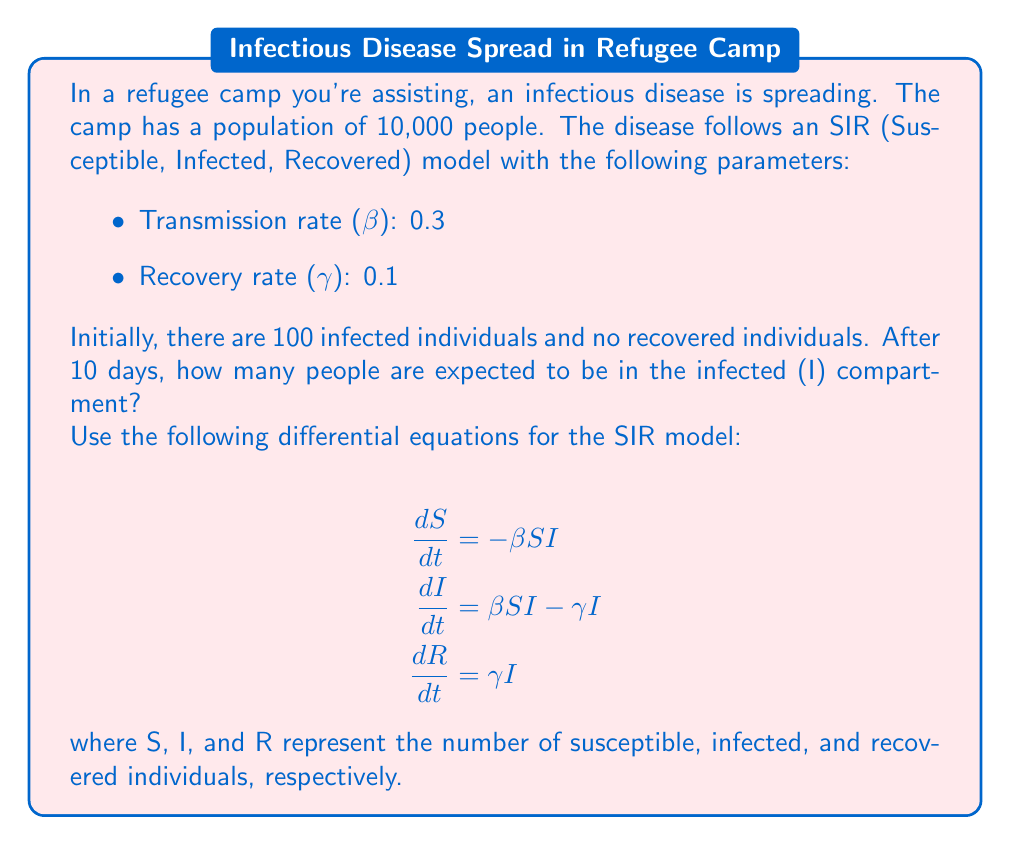Give your solution to this math problem. To solve this problem, we need to use numerical methods to approximate the solution of the SIR model differential equations. We'll use the Euler method with a small time step to estimate the number of infected individuals after 10 days.

1. Initialize the variables:
   S₀ = 9900 (initial susceptible)
   I₀ = 100 (initial infected)
   R₀ = 0 (initial recovered)
   N = 10000 (total population)
   β = 0.3 (transmission rate)
   γ = 0.1 (recovery rate)
   Δt = 0.1 (time step in days)
   T = 10 (total time in days)

2. Calculate the number of steps:
   steps = T / Δt = 10 / 0.1 = 100

3. Use the Euler method to approximate the solution:
   For each step i from 1 to 100:
   
   $$S_{i+1} = S_i + (-\beta S_i I_i / N) \cdot \Delta t$$
   $$I_{i+1} = I_i + (\beta S_i I_i / N - \gamma I_i) \cdot \Delta t$$
   $$R_{i+1} = R_i + (\gamma I_i) \cdot \Delta t$$

4. Implement the algorithm (pseudo-code):

```
S = 9900
I = 100
R = 0
N = 10000
beta = 0.3
gamma = 0.1
dt = 0.1

for i in range(100):
    dS = -beta * S * I / N
    dI = beta * S * I / N - gamma * I
    dR = gamma * I
    
    S = S + dS * dt
    I = I + dI * dt
    R = R + dR * dt
```

5. After running this algorithm, we find that after 10 days (100 steps):
   I ≈ 1629.7

Therefore, after 10 days, approximately 1630 people are expected to be in the infected (I) compartment.
Answer: Approximately 1630 people 